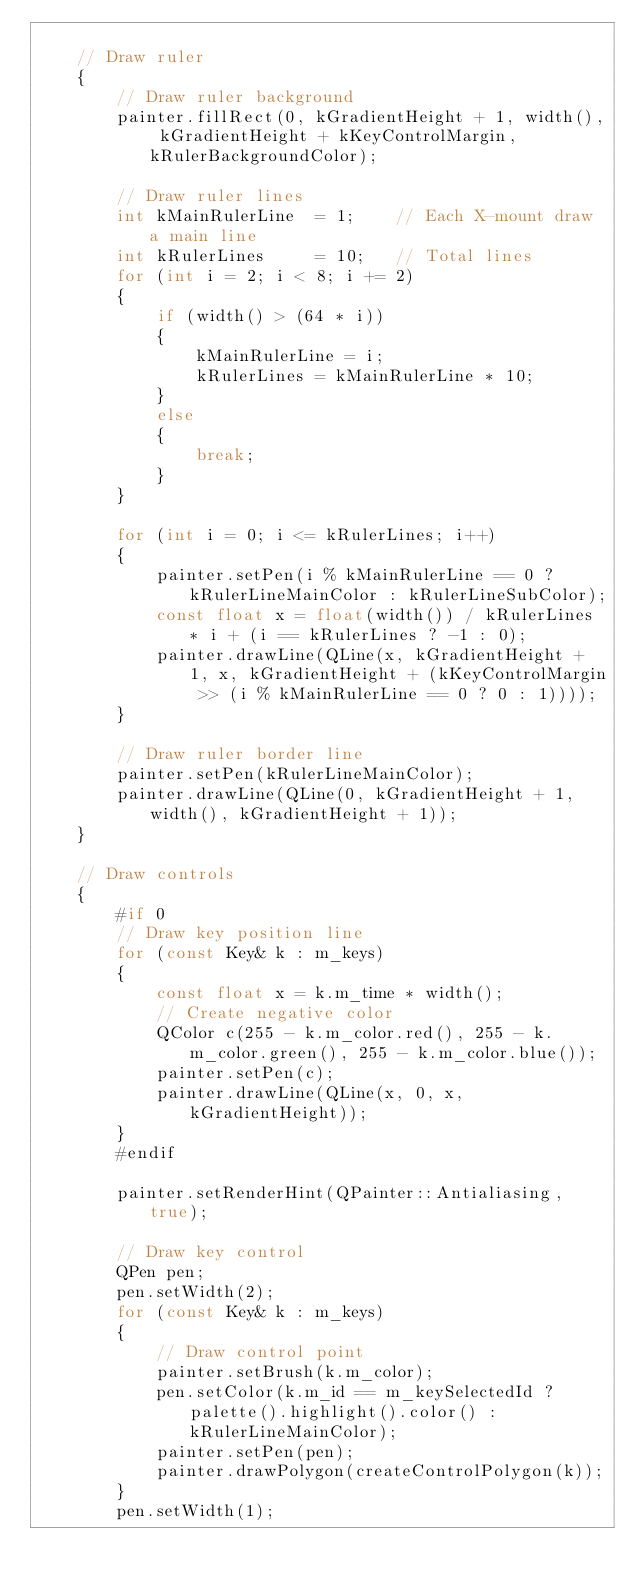<code> <loc_0><loc_0><loc_500><loc_500><_C++_>
    // Draw ruler
    {
        // Draw ruler background
        painter.fillRect(0, kGradientHeight + 1, width(), kGradientHeight + kKeyControlMargin, kRulerBackgroundColor);

        // Draw ruler lines
        int kMainRulerLine  = 1;    // Each X-mount draw a main line
        int kRulerLines     = 10;   // Total lines
        for (int i = 2; i < 8; i += 2)
        {
            if (width() > (64 * i))
            {
                kMainRulerLine = i;
                kRulerLines = kMainRulerLine * 10;
            }
            else
            {
                break;
            }
        }

        for (int i = 0; i <= kRulerLines; i++)
        {
            painter.setPen(i % kMainRulerLine == 0 ? kRulerLineMainColor : kRulerLineSubColor);
            const float x = float(width()) / kRulerLines * i + (i == kRulerLines ? -1 : 0);
            painter.drawLine(QLine(x, kGradientHeight + 1, x, kGradientHeight + (kKeyControlMargin >> (i % kMainRulerLine == 0 ? 0 : 1))));
        }

        // Draw ruler border line
        painter.setPen(kRulerLineMainColor);
        painter.drawLine(QLine(0, kGradientHeight + 1, width(), kGradientHeight + 1));
    }

    // Draw controls
    {
        #if 0
        // Draw key position line
        for (const Key& k : m_keys)
        {
            const float x = k.m_time * width();
            // Create negative color
            QColor c(255 - k.m_color.red(), 255 - k.m_color.green(), 255 - k.m_color.blue());
            painter.setPen(c);
            painter.drawLine(QLine(x, 0, x, kGradientHeight));
        }
        #endif

        painter.setRenderHint(QPainter::Antialiasing, true);

        // Draw key control
        QPen pen;
        pen.setWidth(2);
        for (const Key& k : m_keys)
        {
            // Draw control point
            painter.setBrush(k.m_color);
            pen.setColor(k.m_id == m_keySelectedId ? palette().highlight().color() : kRulerLineMainColor);
            painter.setPen(pen);
            painter.drawPolygon(createControlPolygon(k));
        }
        pen.setWidth(1);</code> 